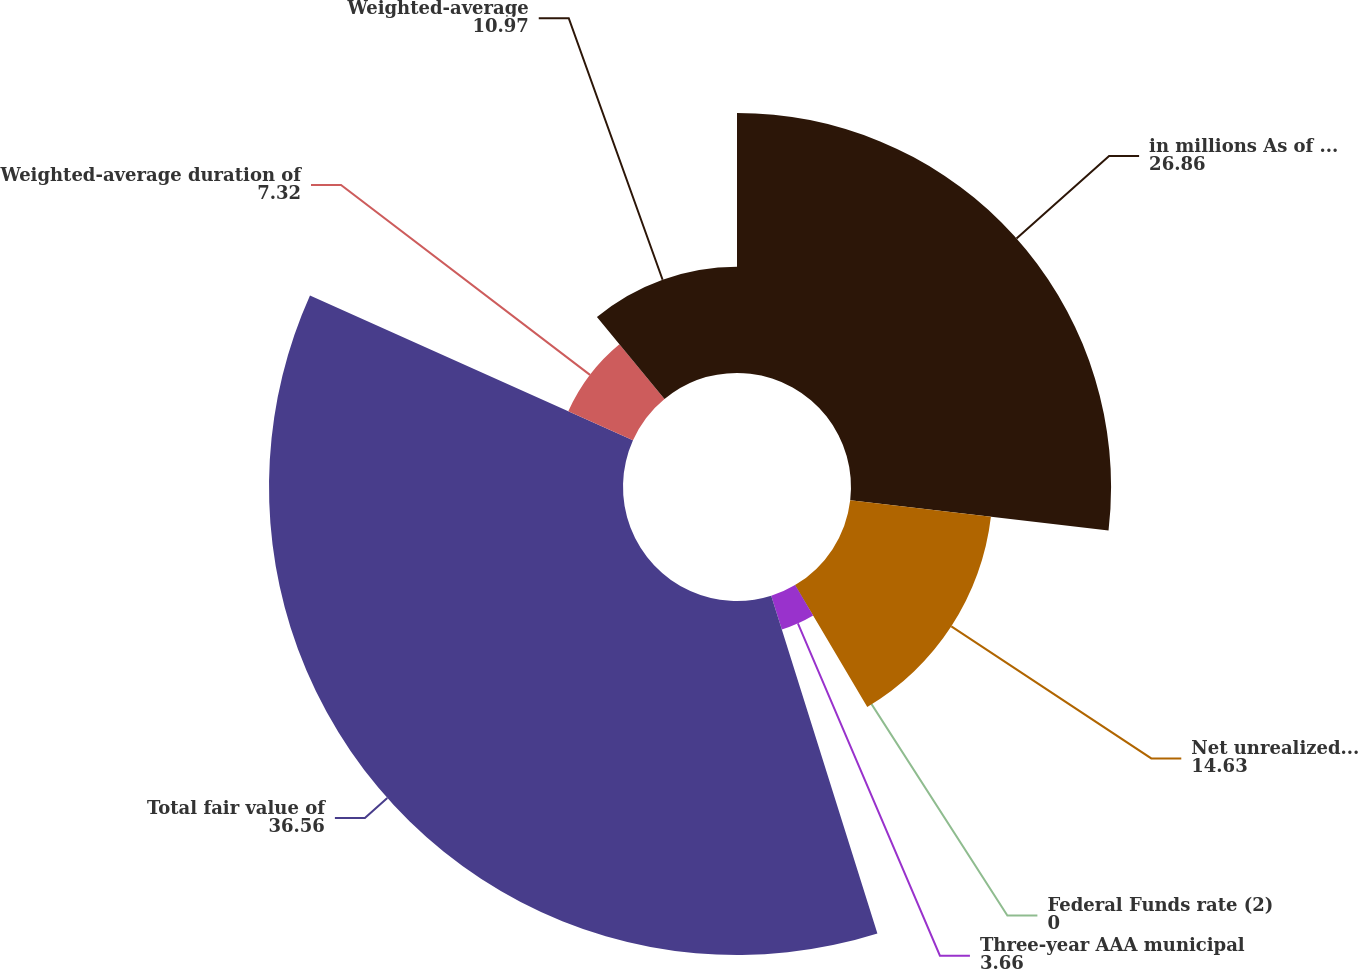Convert chart. <chart><loc_0><loc_0><loc_500><loc_500><pie_chart><fcel>in millions As of May 31<fcel>Net unrealized gains on<fcel>Federal Funds rate (2)<fcel>Three-year AAA municipal<fcel>Total fair value of<fcel>Weighted-average duration of<fcel>Weighted-average<nl><fcel>26.86%<fcel>14.63%<fcel>0.0%<fcel>3.66%<fcel>36.56%<fcel>7.32%<fcel>10.97%<nl></chart> 